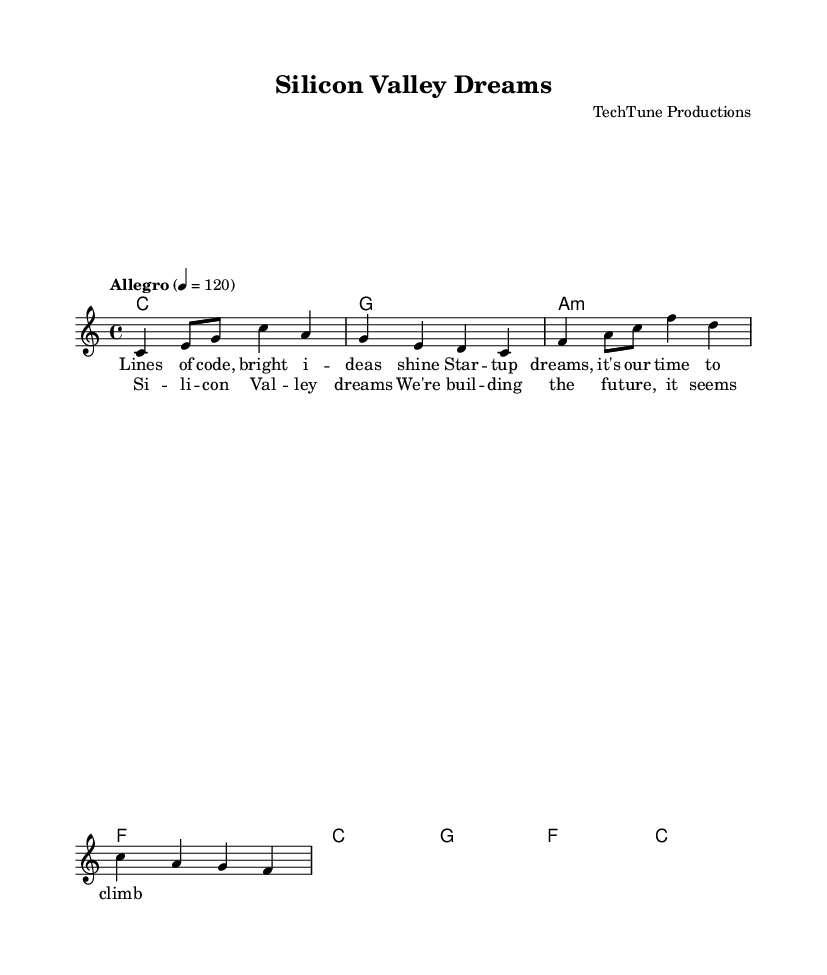What is the key signature of this music? The key signature is C major, which has no sharps or flats.
Answer: C major What is the time signature of the piece? The time signature is indicated at the beginning of the score and is 4/4.
Answer: 4/4 What is the tempo marking for this piece? The tempo marking is specified as "Allegro," with a metronome marking of 120 beats per minute.
Answer: Allegro How many measures are in the melody section? Counting each bar in the melody part reveals there are four measures or bars (separated by vertical lines).
Answer: Four Identify the first chord in the harmony. The first chord listed in the harmony is a C major chord, indicated by the letter C.
Answer: C What is the lyrics theme in the chorus? The theme of the chorus revolves around dreams and future aspirations related to Silicon Valley and technology, indicated by lines from the provided lyrics.
Answer: Dreams and future What is the last note of the melody line? The last note of the melody is F in the last measure, as seen at the end of the melodic part.
Answer: F 